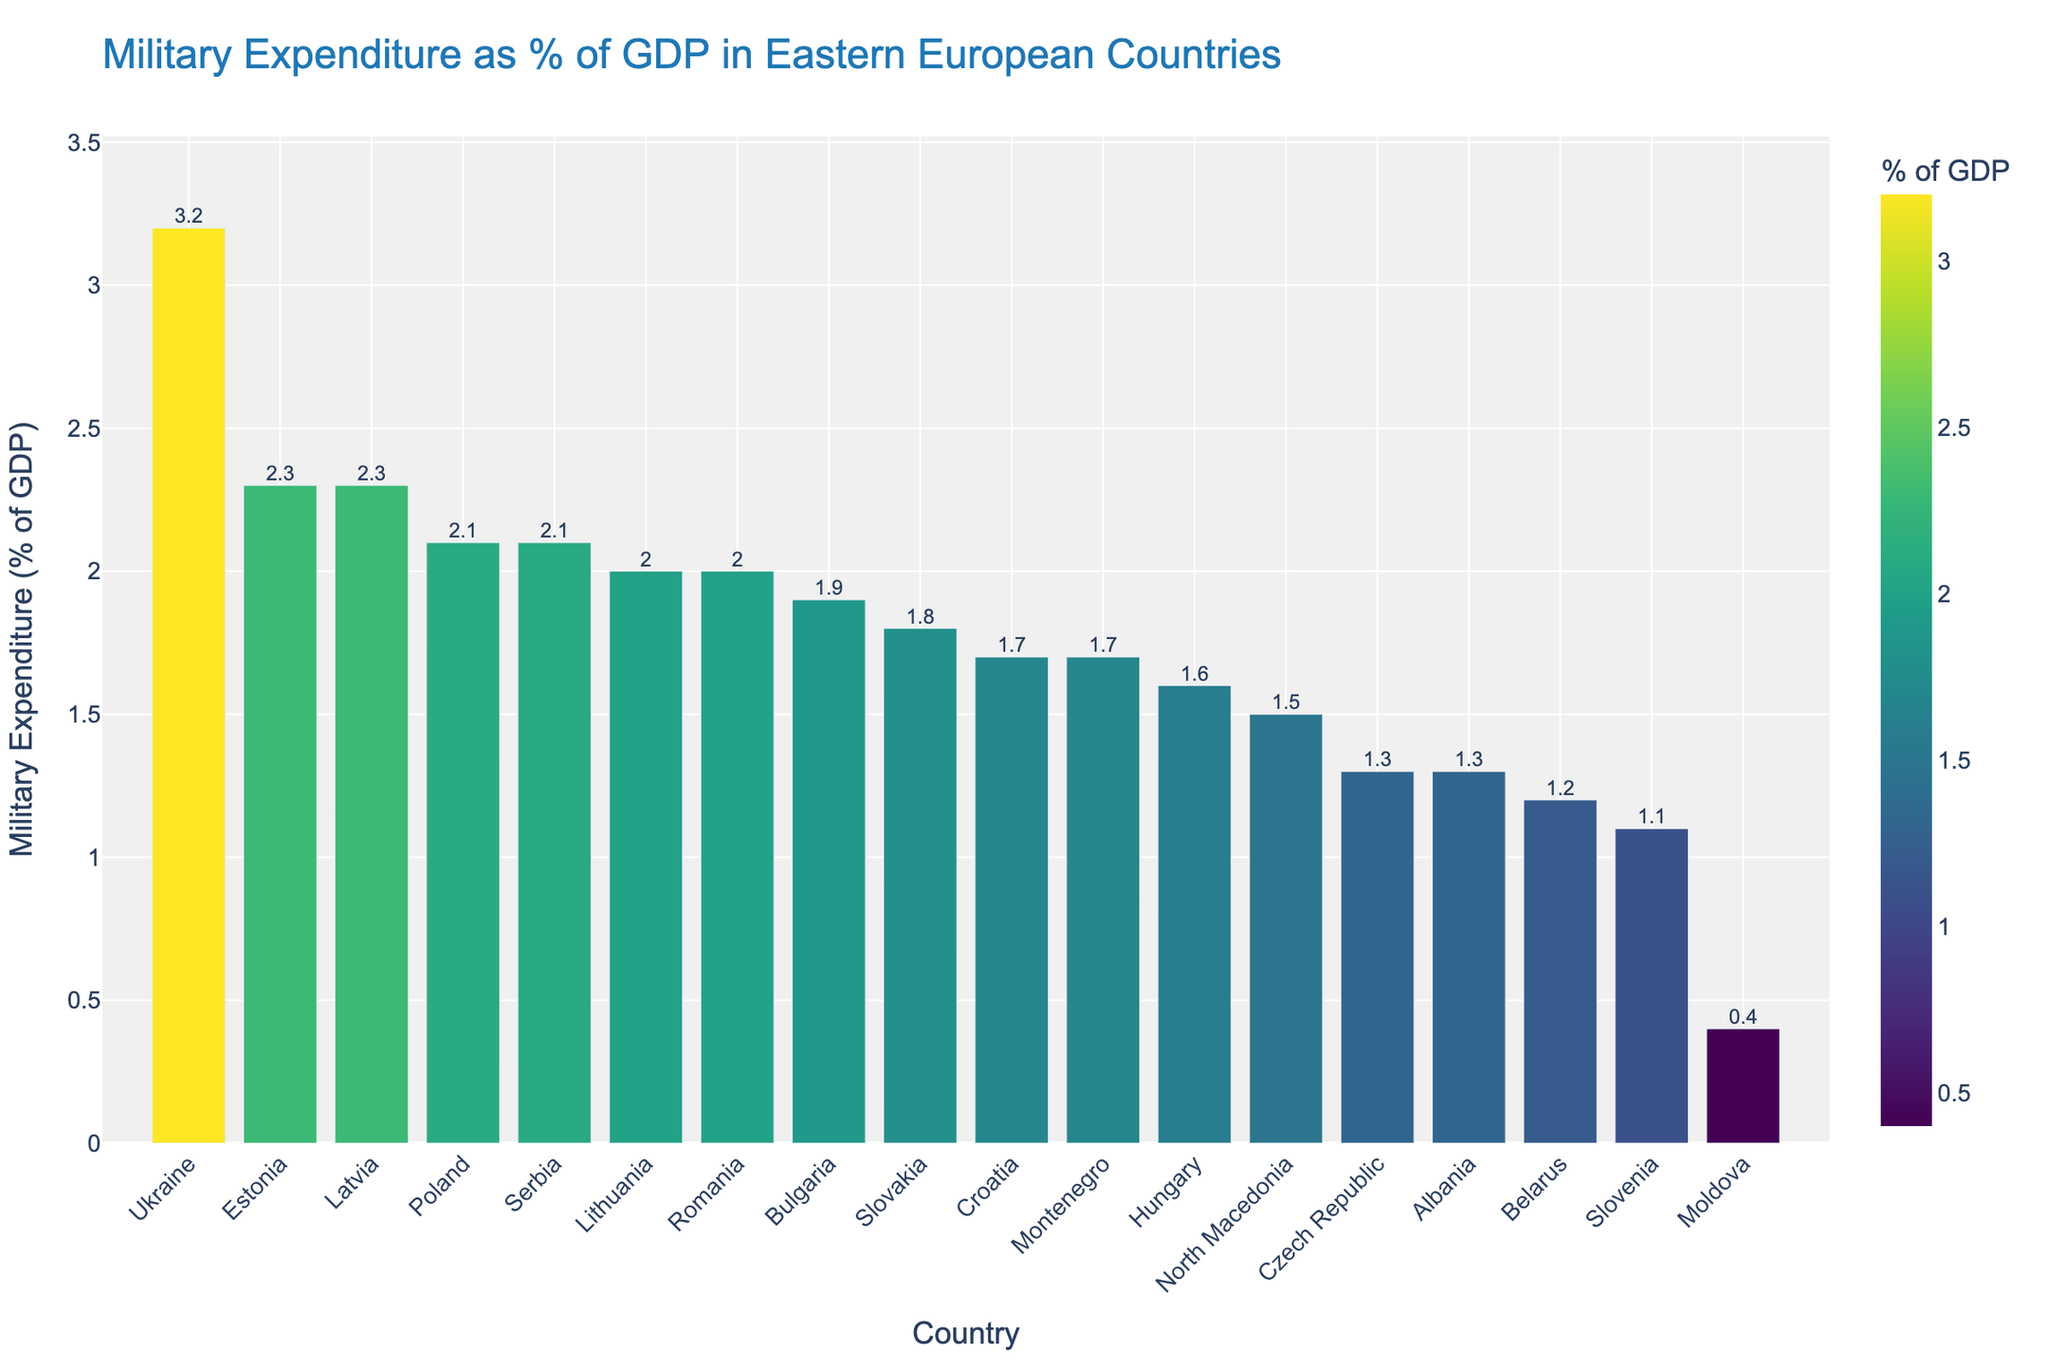Which country has the highest military expenditure as a percentage of GDP? By observing the tallest bar in the chart, we see that Ukraine has the highest military expenditure as a percentage of GDP, standing at 3.2%.
Answer: Ukraine Which two countries have the same highest military expenditure as a percentage of GDP after Ukraine? By looking at the bars, we notice that both Latvia and Estonia have military expenditures at 2.3% of GDP.
Answer: Latvia and Estonia What is the difference in military expenditure as a percentage of GDP between Poland and Hungary? From the chart, Poland’s expenditure is 2.1% and Hungary’s is 1.6%. Subtracting Hungary’s percentage from Poland’s gives 2.1% - 1.6% = 0.5%.
Answer: 0.5% Which countries have a military expenditure percentage equal to Lithuania? From the chart, we see that both Lithuania and Romania have a military expenditure of 2.0% of GDP.
Answer: Lithuania and Romania What is the average military expenditure percentage of Latvia, Estonia, and Bulgaria? The expenditures are 2.3%, 2.3%, and 1.9% respectively. Adding these gives 2.3 + 2.3 + 1.9 = 6.5. The average is 6.5 / 3 = 2.17%.
Answer: 2.17% Which country spends the least on military as a percentage of GDP? Observing the shortest bar, we find that Moldova has the lowest military expenditure as a percentage of GDP at 0.4%.
Answer: Moldova How much higher is Serbia's military expenditure compared to North Macedonia's? Serbia has a military expenditure of 2.1% and North Macedonia has 1.5%. The difference is 2.1% - 1.5% = 0.6%.
Answer: 0.6% What is the total sum of military expenditures as a percentage of GDP for Slovakia, Croatia, and Montenegro? By adding the values, we get 1.8% (Slovakia) + 1.7% (Croatia) + 1.7% (Montenegro) = 5.2%.
Answer: 5.2% Which country has a military expenditure closest to the average of all Eastern European countries listed? First, find the average by summing all expenditures: (2.1 + 2.0 + 1.6 + 1.3 + 1.9 + 1.8 + 1.7 + 2.0 + 2.3 + 2.3 + 1.1 + 1.5 + 1.3 + 1.7 + 0.4 + 1.2 + 3.2 + 2.1) = 36.4%. The average is 36.4% / 18 = 2.02%. Romania and Lithuania both have 2.0%, closest to the average.
Answer: Romania and Lithuania Which two countries have the greatest difference in military expenditure percentages? Observing the bars, Ukraine has the highest at 3.2% and Moldova the lowest at 0.4%. The difference is 3.2% - 0.4% = 2.8%.
Answer: Ukraine and Moldova 